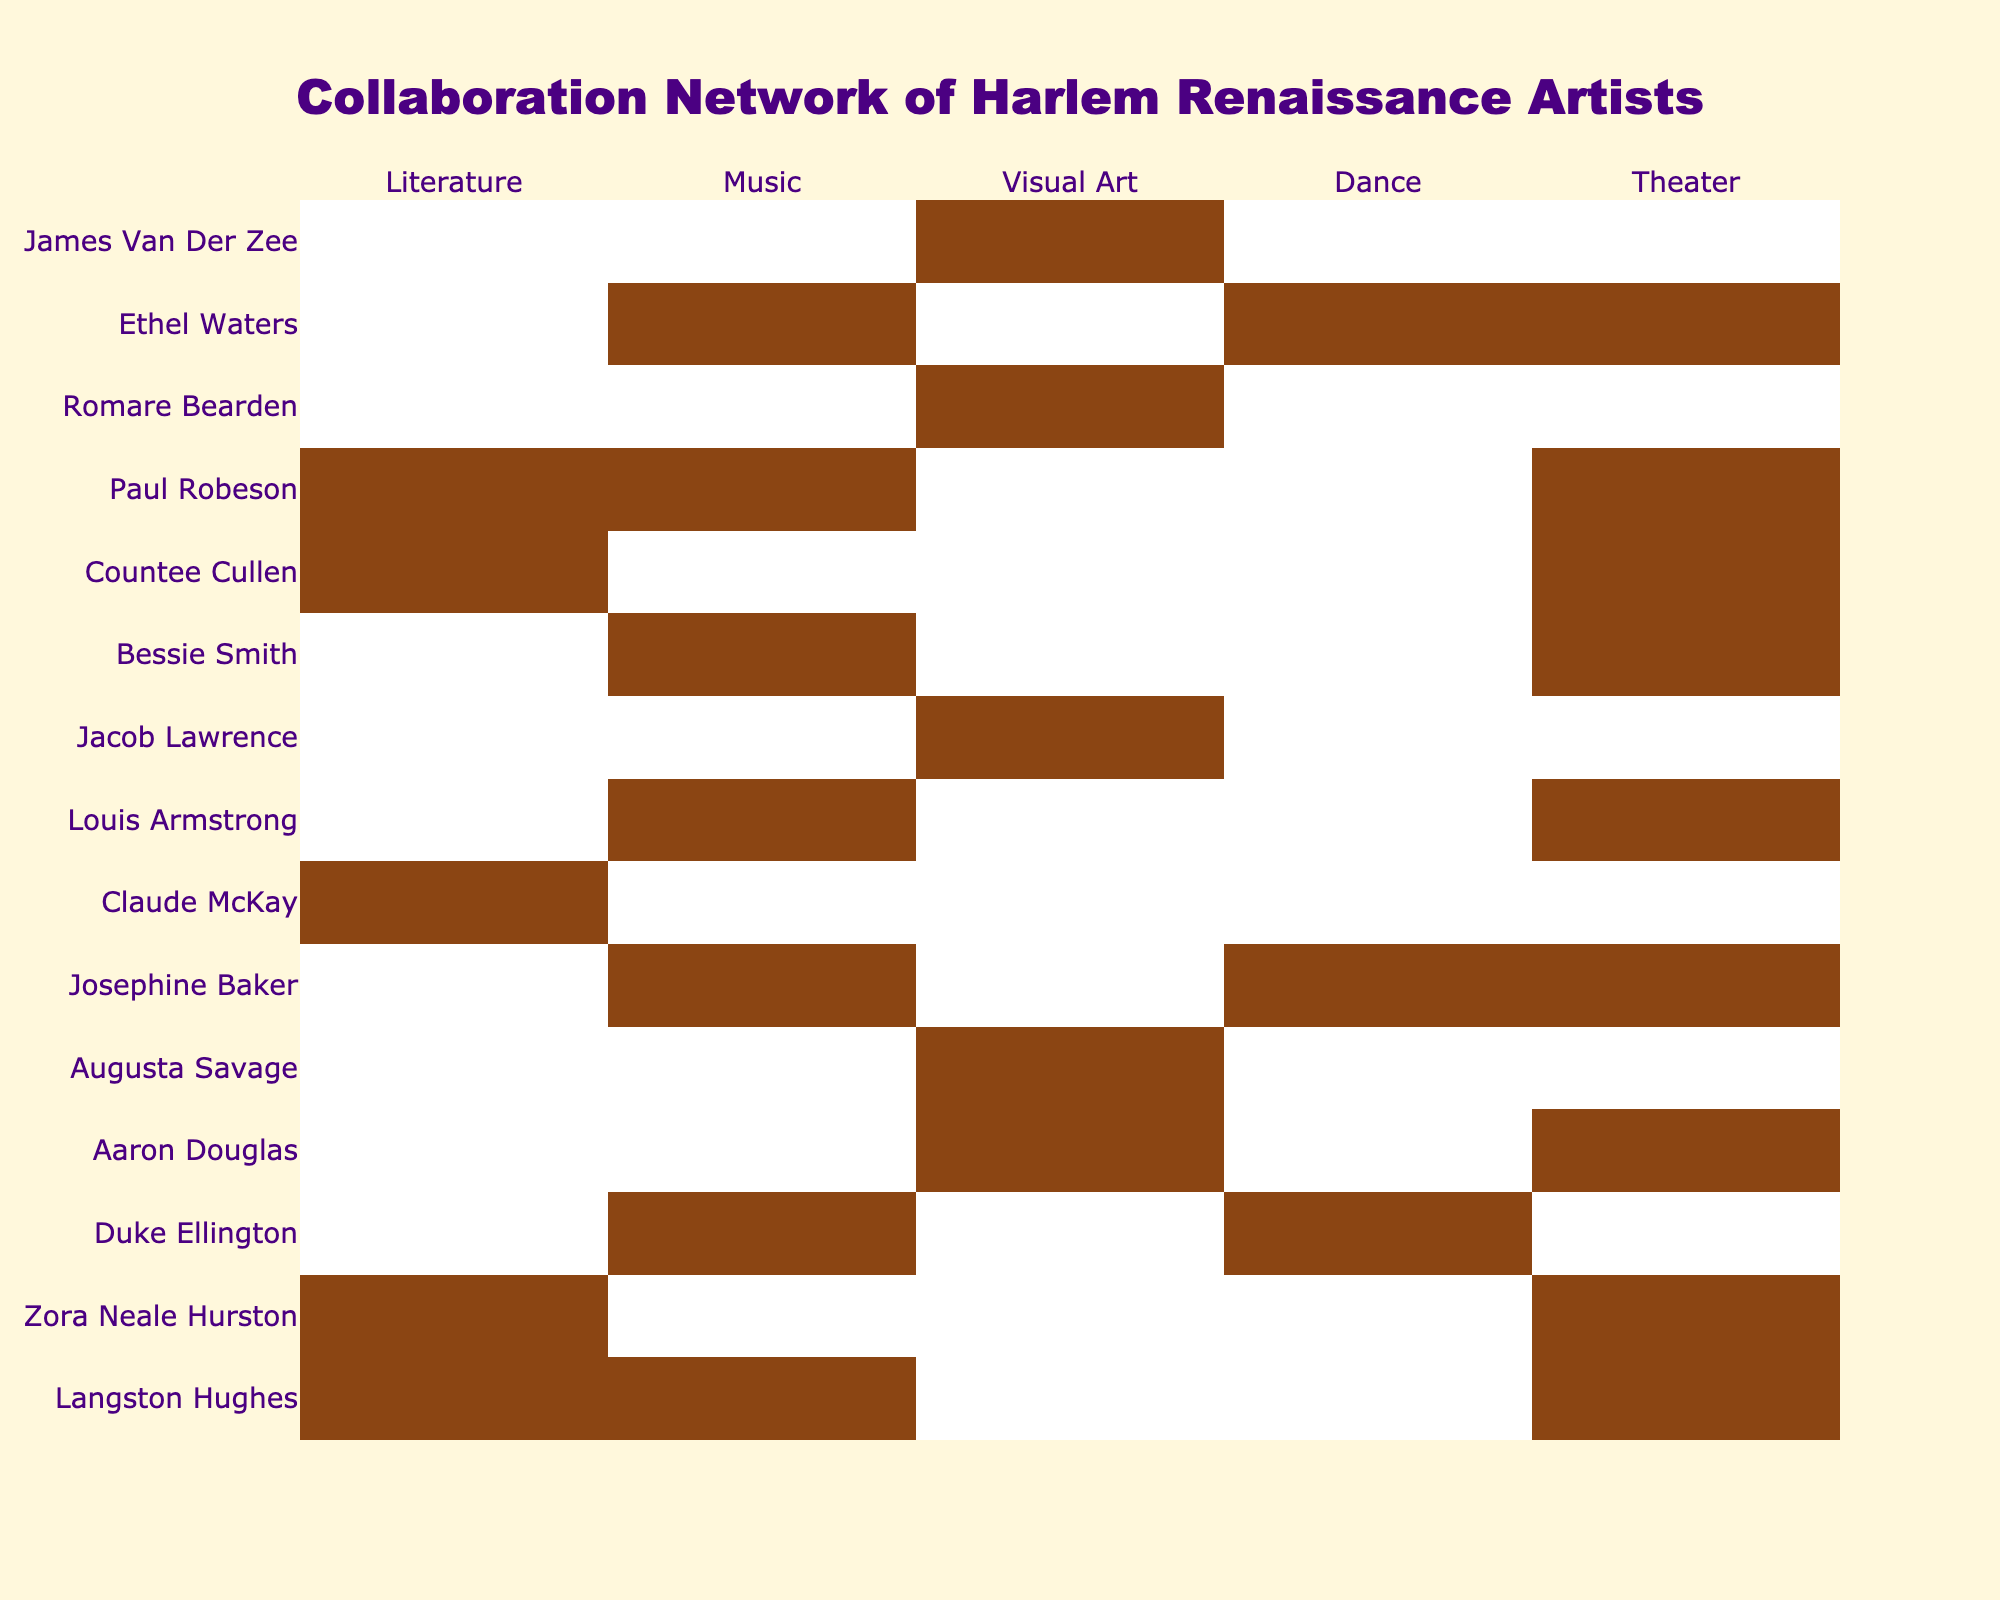What is the total number of artists listed in the table? The table contains a list under the 'Artist' column. Counting the artists, there are 15 names total.
Answer: 15 Which artist collaborated in Literature and Music but not in Visual Art? Looking at the table, Langston Hughes has a '1' in both Literature and Music columns, but a '0' in Visual Art.
Answer: Langston Hughes How many artists excelled in Visual Art but not in Theater? Checking the Visual Art column, the artists who have '1' in Visual Art but '0' in Theater are Augusta Savage, Jacob Lawrence, and Romare Bearden, totaling three artists.
Answer: 3 Did Josephine Baker work in Dance? In the table, Josephine Baker has a '1' under the Dance column, indicating she did collaborate in that category.
Answer: Yes Which art form is most commonly collaborated in by the artists listed? By examining the columns for each art form, we can tally the total '1's: Literature (7), Music (8), Visual Art (6), Dance (5), and Theater (7). The most common is Music with 8 collaborations.
Answer: Music How many artists participated in both Music and Dance? From the table, we see that Duke Ellington, Josephine Baker, and Ethel Waters have '1's in both Music and Dance, which makes it three.
Answer: 3 Which artist contributed to the most art forms? Reviewing each artist, Paul Robeson has a '1' in four categories: Literature, Music, Dance, and Theater. No other artist matches this level of participation.
Answer: Paul Robeson Is there any artist who only participated in Theater? Looking at the table, there are no artists with a '1' only in Theater; all have additional collaborations in other categories.
Answer: No What is the sum of the total collaborations in Music? Counting '1's in the Music column: 1 (Hughes) + 1 (Ellington) + 1 (Baker) + 1 (Smith) + 1 (Robeson) + 1 (Waters) = 6.
Answer: 6 Which two art forms do the greatest number of artists overlap in? By reviewing intersections, the highest overlaps are between Music and Theater. Both have 6 artists participating across the categories.
Answer: Music and Theater 